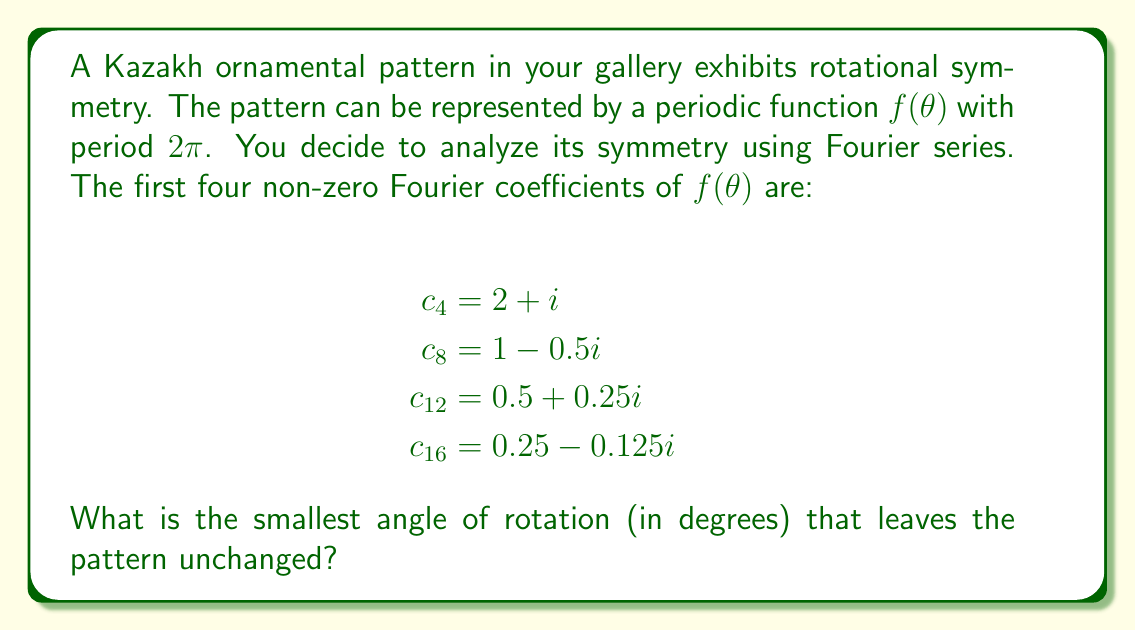Could you help me with this problem? To determine the smallest angle of rotation that leaves the pattern unchanged, we need to analyze the Fourier coefficients:

1) In a Fourier series, the coefficient $c_n$ corresponds to a rotation of $2π/n$ radians or $360°/n$ degrees.

2) The non-zero coefficients are $c_4$, $c_8$, $c_{12}$, and $c_{16}$. This means the pattern repeats every $2π/4 = π/2$ radians at most.

3) To find the smallest angle, we need to find the greatest common divisor (GCD) of the indices of the non-zero coefficients:

   $GCD(4, 8, 12, 16) = 4$

4) This means the fundamental frequency is 4, corresponding to a rotation of:

   $$\frac{360°}{4} = 90°$$

5) We can verify this:
   - A 90° rotation corresponds to $c_4$
   - A 180° rotation corresponds to $c_8$
   - A 270° rotation corresponds to $c_{12}$
   - A 360° rotation corresponds to $c_{16}$

Therefore, the smallest angle of rotation that leaves the pattern unchanged is 90°.
Answer: 90° 